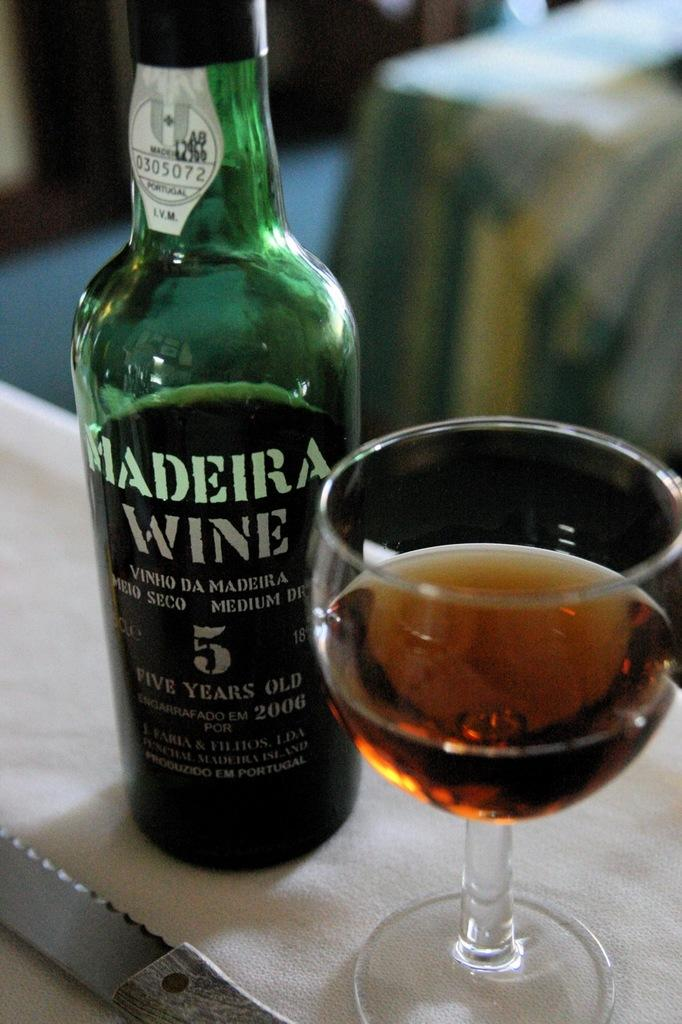<image>
Provide a brief description of the given image. A glass is next to a green bottle that says Madeira Wine. 